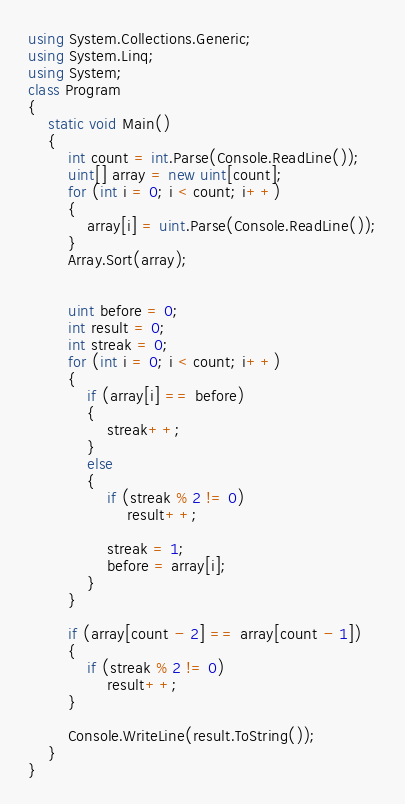<code> <loc_0><loc_0><loc_500><loc_500><_C#_>using System.Collections.Generic;
using System.Linq;
using System;
class Program
{
    static void Main()
    {
        int count = int.Parse(Console.ReadLine());
        uint[] array = new uint[count];
        for (int i = 0; i < count; i++)
        {
            array[i] = uint.Parse(Console.ReadLine());
        }
        Array.Sort(array);


        uint before = 0;
        int result = 0;
        int streak = 0;
        for (int i = 0; i < count; i++)
        {
            if (array[i] == before)
            {
                streak++;
            }
            else
            {
                if (streak % 2 != 0)
                    result++;

                streak = 1;
                before = array[i];
            }
        }

        if (array[count - 2] == array[count - 1])
        {
            if (streak % 2 != 0)
                result++;
        }

        Console.WriteLine(result.ToString());
    }
}</code> 